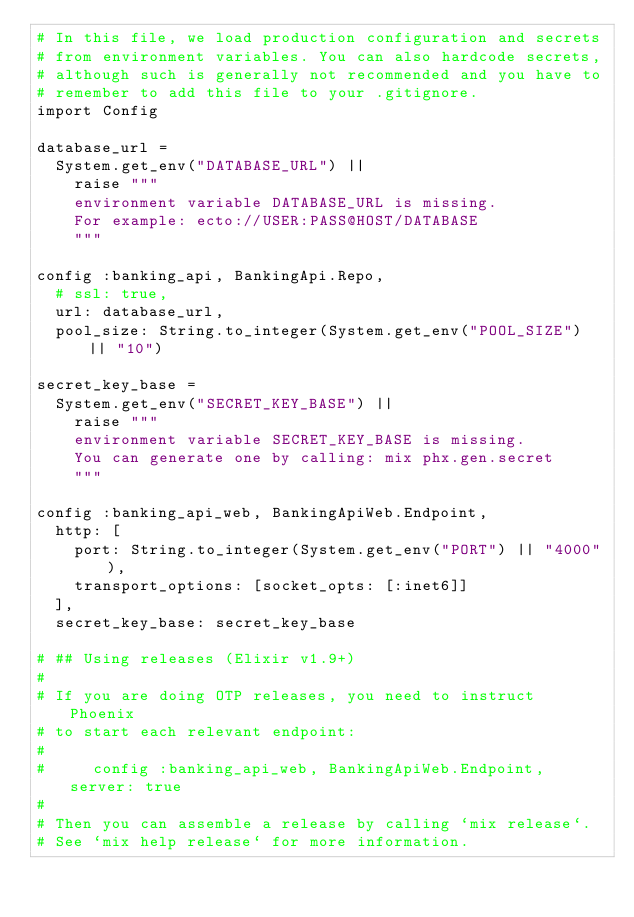Convert code to text. <code><loc_0><loc_0><loc_500><loc_500><_Elixir_># In this file, we load production configuration and secrets
# from environment variables. You can also hardcode secrets,
# although such is generally not recommended and you have to
# remember to add this file to your .gitignore.
import Config

database_url =
  System.get_env("DATABASE_URL") ||
    raise """
    environment variable DATABASE_URL is missing.
    For example: ecto://USER:PASS@HOST/DATABASE
    """

config :banking_api, BankingApi.Repo,
  # ssl: true,
  url: database_url,
  pool_size: String.to_integer(System.get_env("POOL_SIZE") || "10")

secret_key_base =
  System.get_env("SECRET_KEY_BASE") ||
    raise """
    environment variable SECRET_KEY_BASE is missing.
    You can generate one by calling: mix phx.gen.secret
    """

config :banking_api_web, BankingApiWeb.Endpoint,
  http: [
    port: String.to_integer(System.get_env("PORT") || "4000"),
    transport_options: [socket_opts: [:inet6]]
  ],
  secret_key_base: secret_key_base

# ## Using releases (Elixir v1.9+)
#
# If you are doing OTP releases, you need to instruct Phoenix
# to start each relevant endpoint:
#
#     config :banking_api_web, BankingApiWeb.Endpoint, server: true
#
# Then you can assemble a release by calling `mix release`.
# See `mix help release` for more information.
</code> 